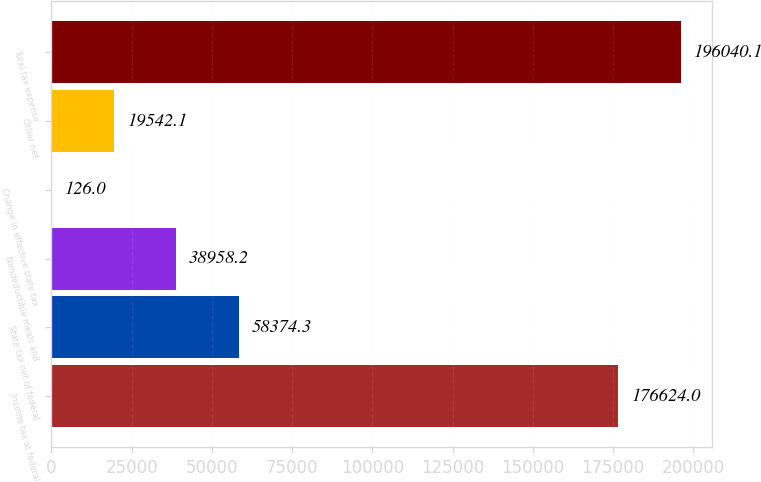<chart> <loc_0><loc_0><loc_500><loc_500><bar_chart><fcel>Income tax at federal<fcel>State tax net of federal<fcel>Nondeductible meals and<fcel>Change in effective state tax<fcel>Other net<fcel>Total tax expense<nl><fcel>176624<fcel>58374.3<fcel>38958.2<fcel>126<fcel>19542.1<fcel>196040<nl></chart> 